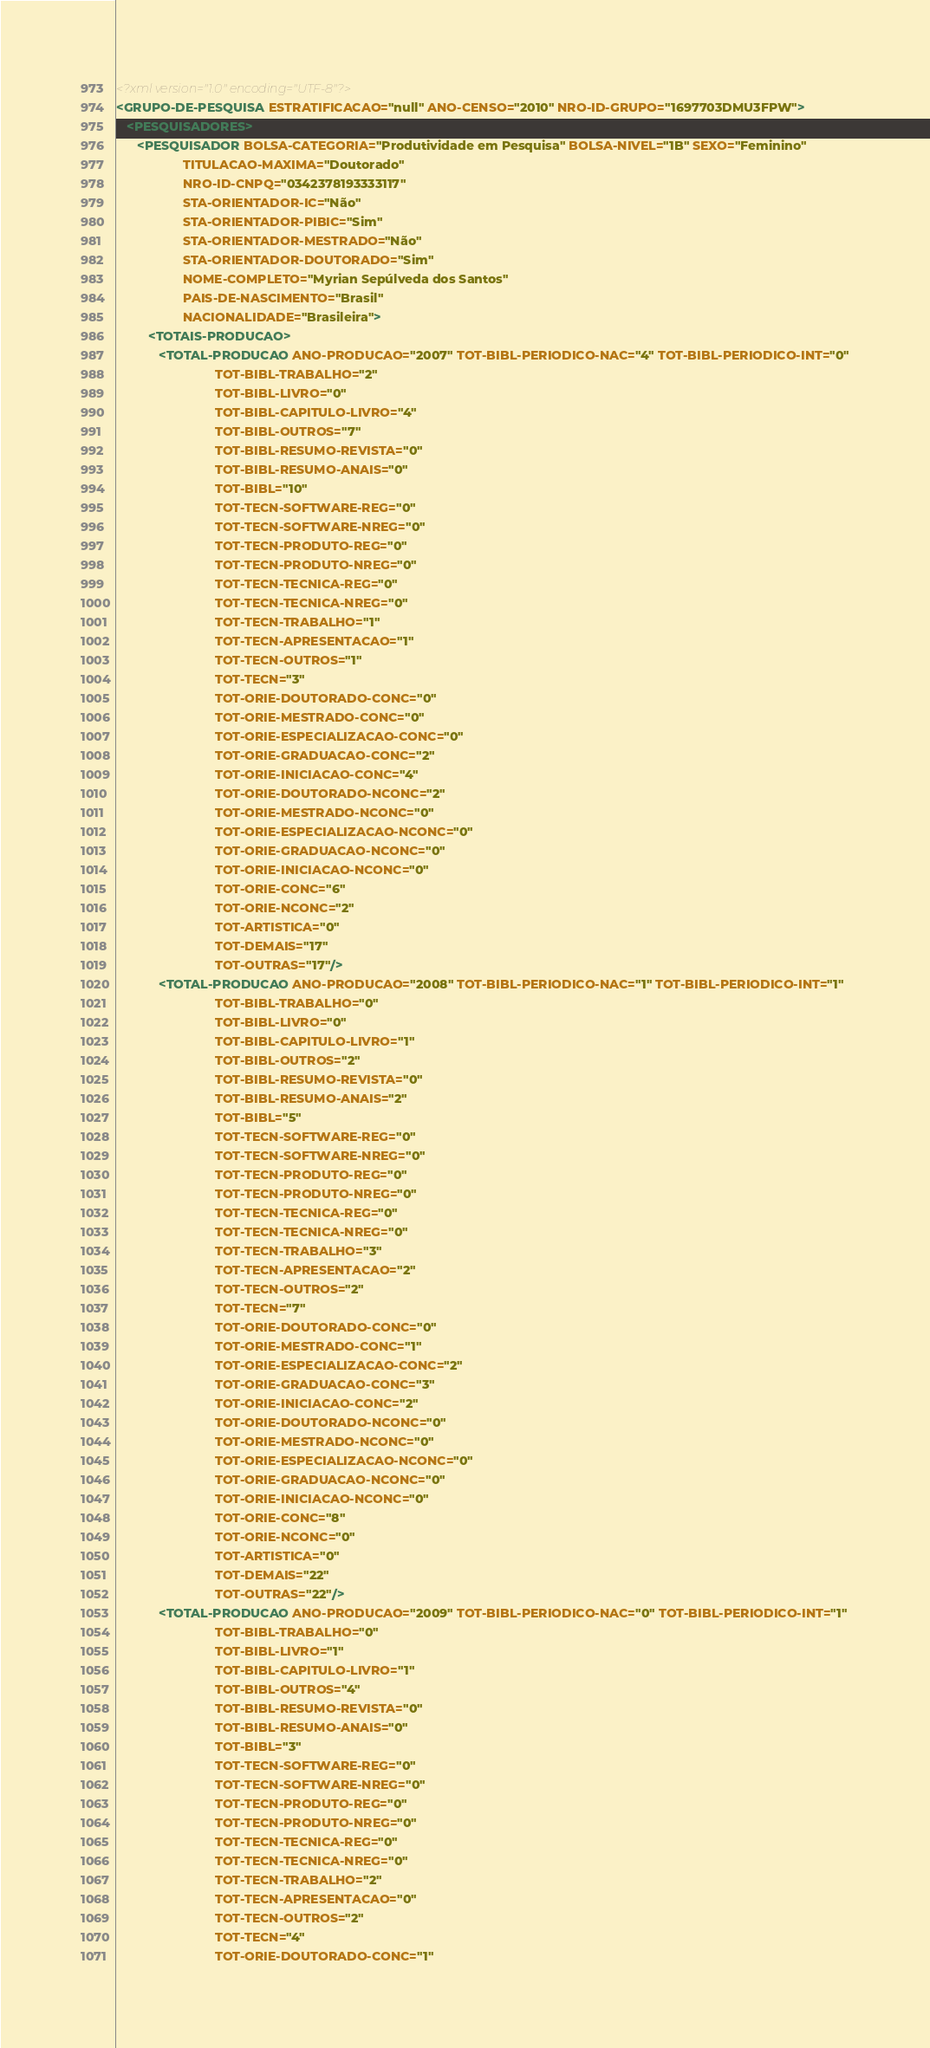<code> <loc_0><loc_0><loc_500><loc_500><_XML_><?xml version="1.0" encoding="UTF-8"?>
<GRUPO-DE-PESQUISA ESTRATIFICACAO="null" ANO-CENSO="2010" NRO-ID-GRUPO="1697703DMU3FPW">
   <PESQUISADORES>
      <PESQUISADOR BOLSA-CATEGORIA="Produtividade em Pesquisa" BOLSA-NIVEL="1B" SEXO="Feminino"
                   TITULACAO-MAXIMA="Doutorado"
                   NRO-ID-CNPQ="0342378193333117"
                   STA-ORIENTADOR-IC="Não"
                   STA-ORIENTADOR-PIBIC="Sim"
                   STA-ORIENTADOR-MESTRADO="Não"
                   STA-ORIENTADOR-DOUTORADO="Sim"
                   NOME-COMPLETO="Myrian Sepúlveda dos Santos"
                   PAIS-DE-NASCIMENTO="Brasil"
                   NACIONALIDADE="Brasileira">
         <TOTAIS-PRODUCAO>
            <TOTAL-PRODUCAO ANO-PRODUCAO="2007" TOT-BIBL-PERIODICO-NAC="4" TOT-BIBL-PERIODICO-INT="0"
                            TOT-BIBL-TRABALHO="2"
                            TOT-BIBL-LIVRO="0"
                            TOT-BIBL-CAPITULO-LIVRO="4"
                            TOT-BIBL-OUTROS="7"
                            TOT-BIBL-RESUMO-REVISTA="0"
                            TOT-BIBL-RESUMO-ANAIS="0"
                            TOT-BIBL="10"
                            TOT-TECN-SOFTWARE-REG="0"
                            TOT-TECN-SOFTWARE-NREG="0"
                            TOT-TECN-PRODUTO-REG="0"
                            TOT-TECN-PRODUTO-NREG="0"
                            TOT-TECN-TECNICA-REG="0"
                            TOT-TECN-TECNICA-NREG="0"
                            TOT-TECN-TRABALHO="1"
                            TOT-TECN-APRESENTACAO="1"
                            TOT-TECN-OUTROS="1"
                            TOT-TECN="3"
                            TOT-ORIE-DOUTORADO-CONC="0"
                            TOT-ORIE-MESTRADO-CONC="0"
                            TOT-ORIE-ESPECIALIZACAO-CONC="0"
                            TOT-ORIE-GRADUACAO-CONC="2"
                            TOT-ORIE-INICIACAO-CONC="4"
                            TOT-ORIE-DOUTORADO-NCONC="2"
                            TOT-ORIE-MESTRADO-NCONC="0"
                            TOT-ORIE-ESPECIALIZACAO-NCONC="0"
                            TOT-ORIE-GRADUACAO-NCONC="0"
                            TOT-ORIE-INICIACAO-NCONC="0"
                            TOT-ORIE-CONC="6"
                            TOT-ORIE-NCONC="2"
                            TOT-ARTISTICA="0"
                            TOT-DEMAIS="17"
                            TOT-OUTRAS="17"/>
            <TOTAL-PRODUCAO ANO-PRODUCAO="2008" TOT-BIBL-PERIODICO-NAC="1" TOT-BIBL-PERIODICO-INT="1"
                            TOT-BIBL-TRABALHO="0"
                            TOT-BIBL-LIVRO="0"
                            TOT-BIBL-CAPITULO-LIVRO="1"
                            TOT-BIBL-OUTROS="2"
                            TOT-BIBL-RESUMO-REVISTA="0"
                            TOT-BIBL-RESUMO-ANAIS="2"
                            TOT-BIBL="5"
                            TOT-TECN-SOFTWARE-REG="0"
                            TOT-TECN-SOFTWARE-NREG="0"
                            TOT-TECN-PRODUTO-REG="0"
                            TOT-TECN-PRODUTO-NREG="0"
                            TOT-TECN-TECNICA-REG="0"
                            TOT-TECN-TECNICA-NREG="0"
                            TOT-TECN-TRABALHO="3"
                            TOT-TECN-APRESENTACAO="2"
                            TOT-TECN-OUTROS="2"
                            TOT-TECN="7"
                            TOT-ORIE-DOUTORADO-CONC="0"
                            TOT-ORIE-MESTRADO-CONC="1"
                            TOT-ORIE-ESPECIALIZACAO-CONC="2"
                            TOT-ORIE-GRADUACAO-CONC="3"
                            TOT-ORIE-INICIACAO-CONC="2"
                            TOT-ORIE-DOUTORADO-NCONC="0"
                            TOT-ORIE-MESTRADO-NCONC="0"
                            TOT-ORIE-ESPECIALIZACAO-NCONC="0"
                            TOT-ORIE-GRADUACAO-NCONC="0"
                            TOT-ORIE-INICIACAO-NCONC="0"
                            TOT-ORIE-CONC="8"
                            TOT-ORIE-NCONC="0"
                            TOT-ARTISTICA="0"
                            TOT-DEMAIS="22"
                            TOT-OUTRAS="22"/>
            <TOTAL-PRODUCAO ANO-PRODUCAO="2009" TOT-BIBL-PERIODICO-NAC="0" TOT-BIBL-PERIODICO-INT="1"
                            TOT-BIBL-TRABALHO="0"
                            TOT-BIBL-LIVRO="1"
                            TOT-BIBL-CAPITULO-LIVRO="1"
                            TOT-BIBL-OUTROS="4"
                            TOT-BIBL-RESUMO-REVISTA="0"
                            TOT-BIBL-RESUMO-ANAIS="0"
                            TOT-BIBL="3"
                            TOT-TECN-SOFTWARE-REG="0"
                            TOT-TECN-SOFTWARE-NREG="0"
                            TOT-TECN-PRODUTO-REG="0"
                            TOT-TECN-PRODUTO-NREG="0"
                            TOT-TECN-TECNICA-REG="0"
                            TOT-TECN-TECNICA-NREG="0"
                            TOT-TECN-TRABALHO="2"
                            TOT-TECN-APRESENTACAO="0"
                            TOT-TECN-OUTROS="2"
                            TOT-TECN="4"
                            TOT-ORIE-DOUTORADO-CONC="1"</code> 